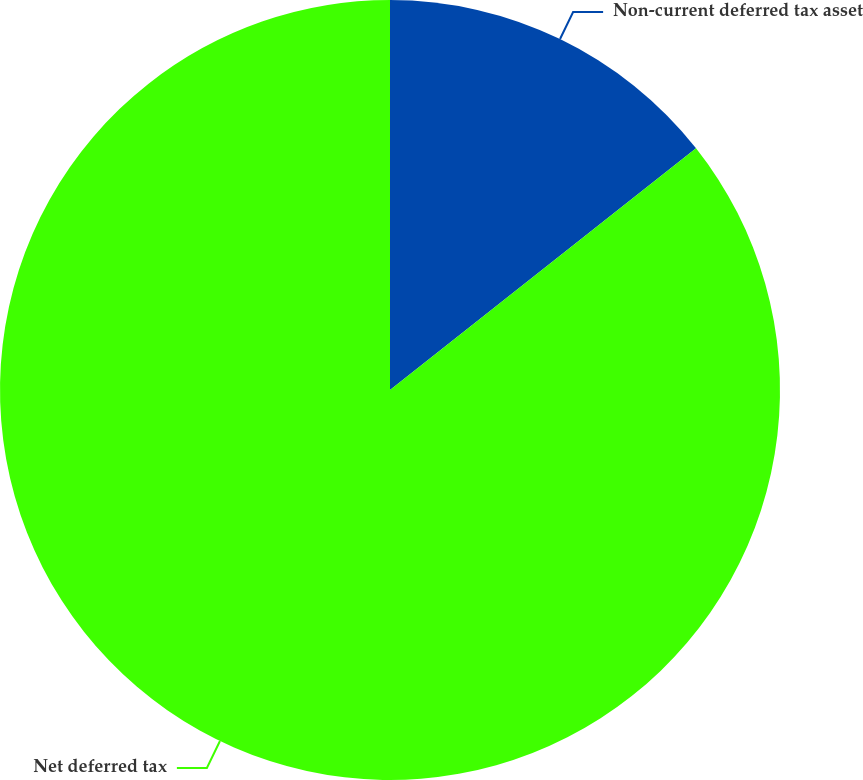Convert chart to OTSL. <chart><loc_0><loc_0><loc_500><loc_500><pie_chart><fcel>Non-current deferred tax asset<fcel>Net deferred tax<nl><fcel>14.36%<fcel>85.64%<nl></chart> 